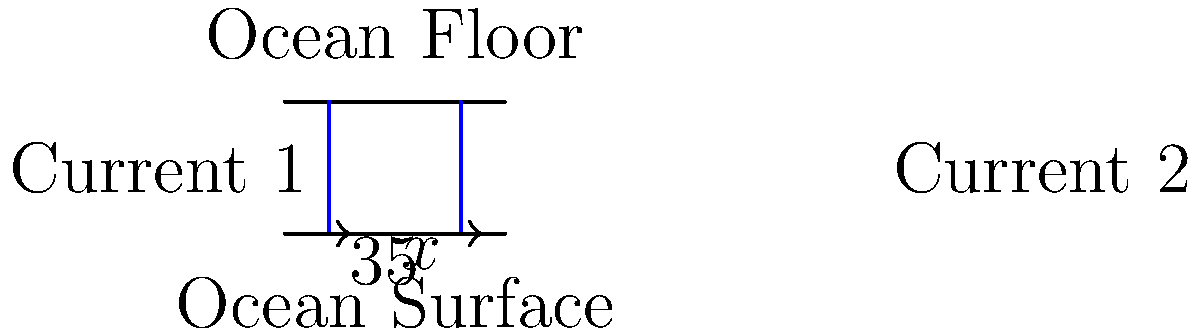In a marine biology study of ocean currents, two parallel currents are modeled using transversal lines across the ocean depth. Current 1 forms a 35° angle with the ocean surface. If the sum of the corresponding angles formed by the two currents with the ocean surface is 130°, what is the angle $x$ formed by Current 2 with the ocean surface? Let's approach this step-by-step:

1) First, recall that when parallel lines are cut by a transversal, corresponding angles are equal.

2) In this case, the ocean surface and ocean floor represent parallel lines, and the two currents are transversals.

3) We're given that the angle formed by Current 1 with the ocean surface is 35°.

4) We're also told that the sum of the corresponding angles formed by the two currents with the ocean surface is 130°.

5) Let's set up an equation:
   $35° + x° = 130°$

6) To solve for $x$, we simply subtract 35° from both sides:
   $x° = 130° - 35°$
   $x° = 95°$

Therefore, the angle $x$ formed by Current 2 with the ocean surface is 95°.
Answer: $95°$ 